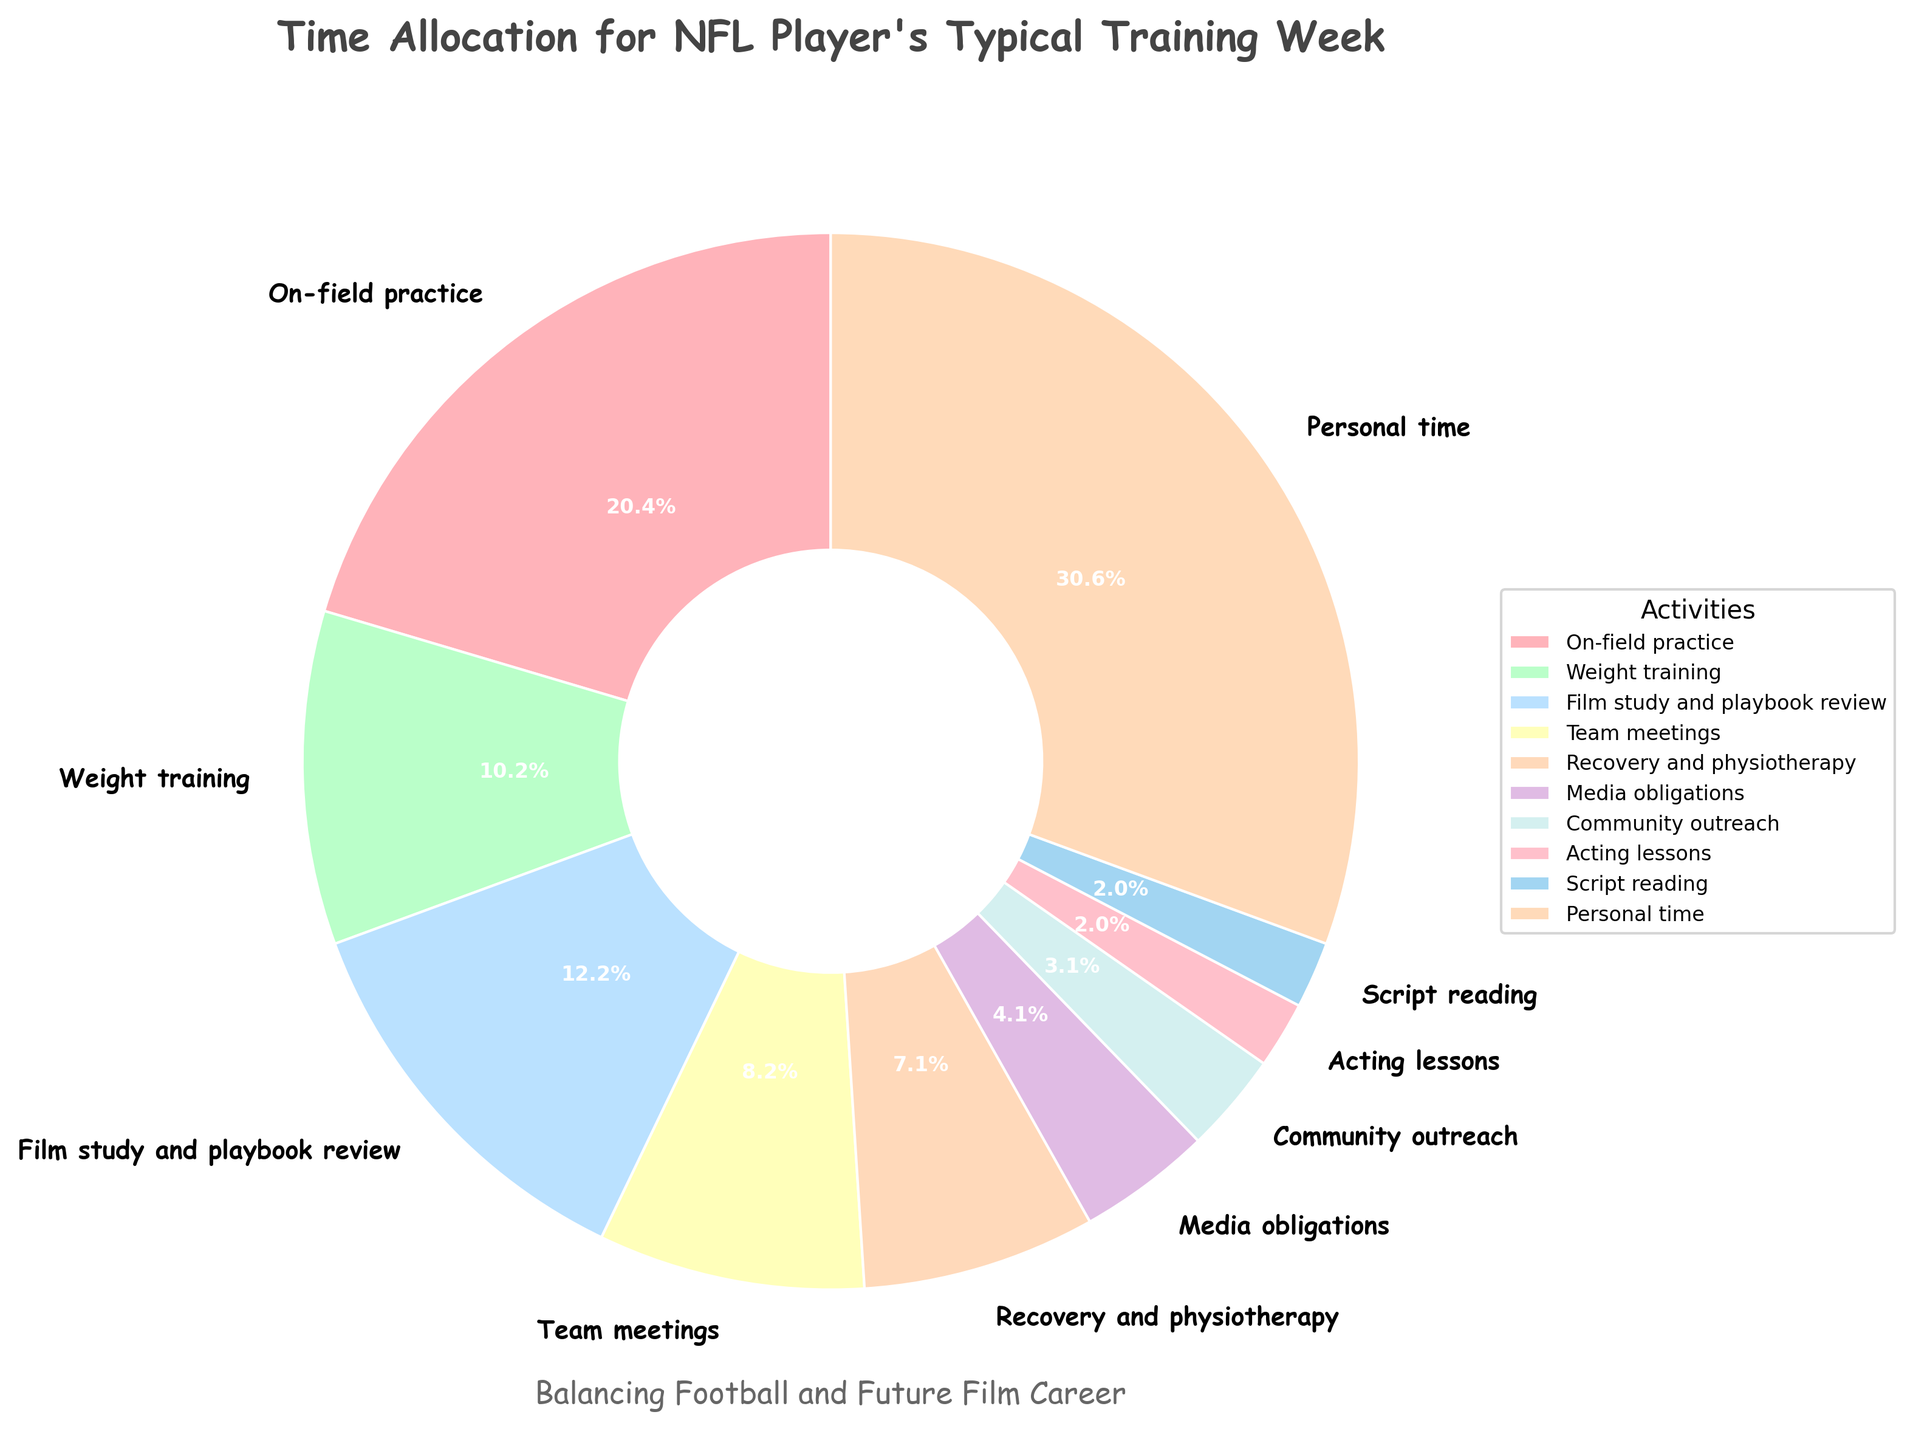How many hours in total are spent on football-related activities (excluding personal time, acting lessons, and script reading)? Sum the hours for all football-related activities: On-field practice (20) + Weight training (10) + Film study and playbook review (12) + Team meetings (8) + Recovery and physiotherapy (7) + Media obligations (4) + Community outreach (3) = 64 hours
Answer: 64 hours Which activity takes up a larger proportion of the week: film study and playbook review or weight training? Film study and playbook review has 12 hours, which is greater than weight training's 10 hours.
Answer: Film study and playbook review How much more time is allocated to personal time compared to on-field practice? Time for personal time is 30 hours, on-field practice is 20 hours. The difference is 30 - 20 = 10 hours
Answer: 10 hours Which activity has the smallest allocation of hours in the week? Acting lessons and script reading both have the smallest allocation with 2 hours each.
Answer: Acting lessons and script reading What is the average time spent on personal development activities (acting lessons and script reading)? The total time for personal development activities is: Acting lessons (2) + script reading (2). There are 2 activities, so the average is (2 + 2) / 2 = 2 hours
Answer: 2 hours If you combine the hours for team meetings and media obligations, do they surpass the hours spent on film study and playbook review? Team meetings (8) + Media obligations (4) = 12 hours. Film study and playbook review is also 12 hours. So, they are equal.
Answer: No Which activity takes up the most visual space in the pie chart and what is its percentage? Personal time takes up the most visual space and, based on the pie chart, it is allocated 30% of the total time.
Answer: Personal time, 30% How many hours are dedicated to activities outside of football (acting lessons, script reading, and personal time)? Acting lessons (2) + script reading (2) + personal time (30) = 34 hours
Answer: 34 hours Recovery and physiotherapy: is it more or less than team meetings in terms of hours? Recovery and physiotherapy is 7 hours, which is less than team meetings' 8 hours.
Answer: Less 